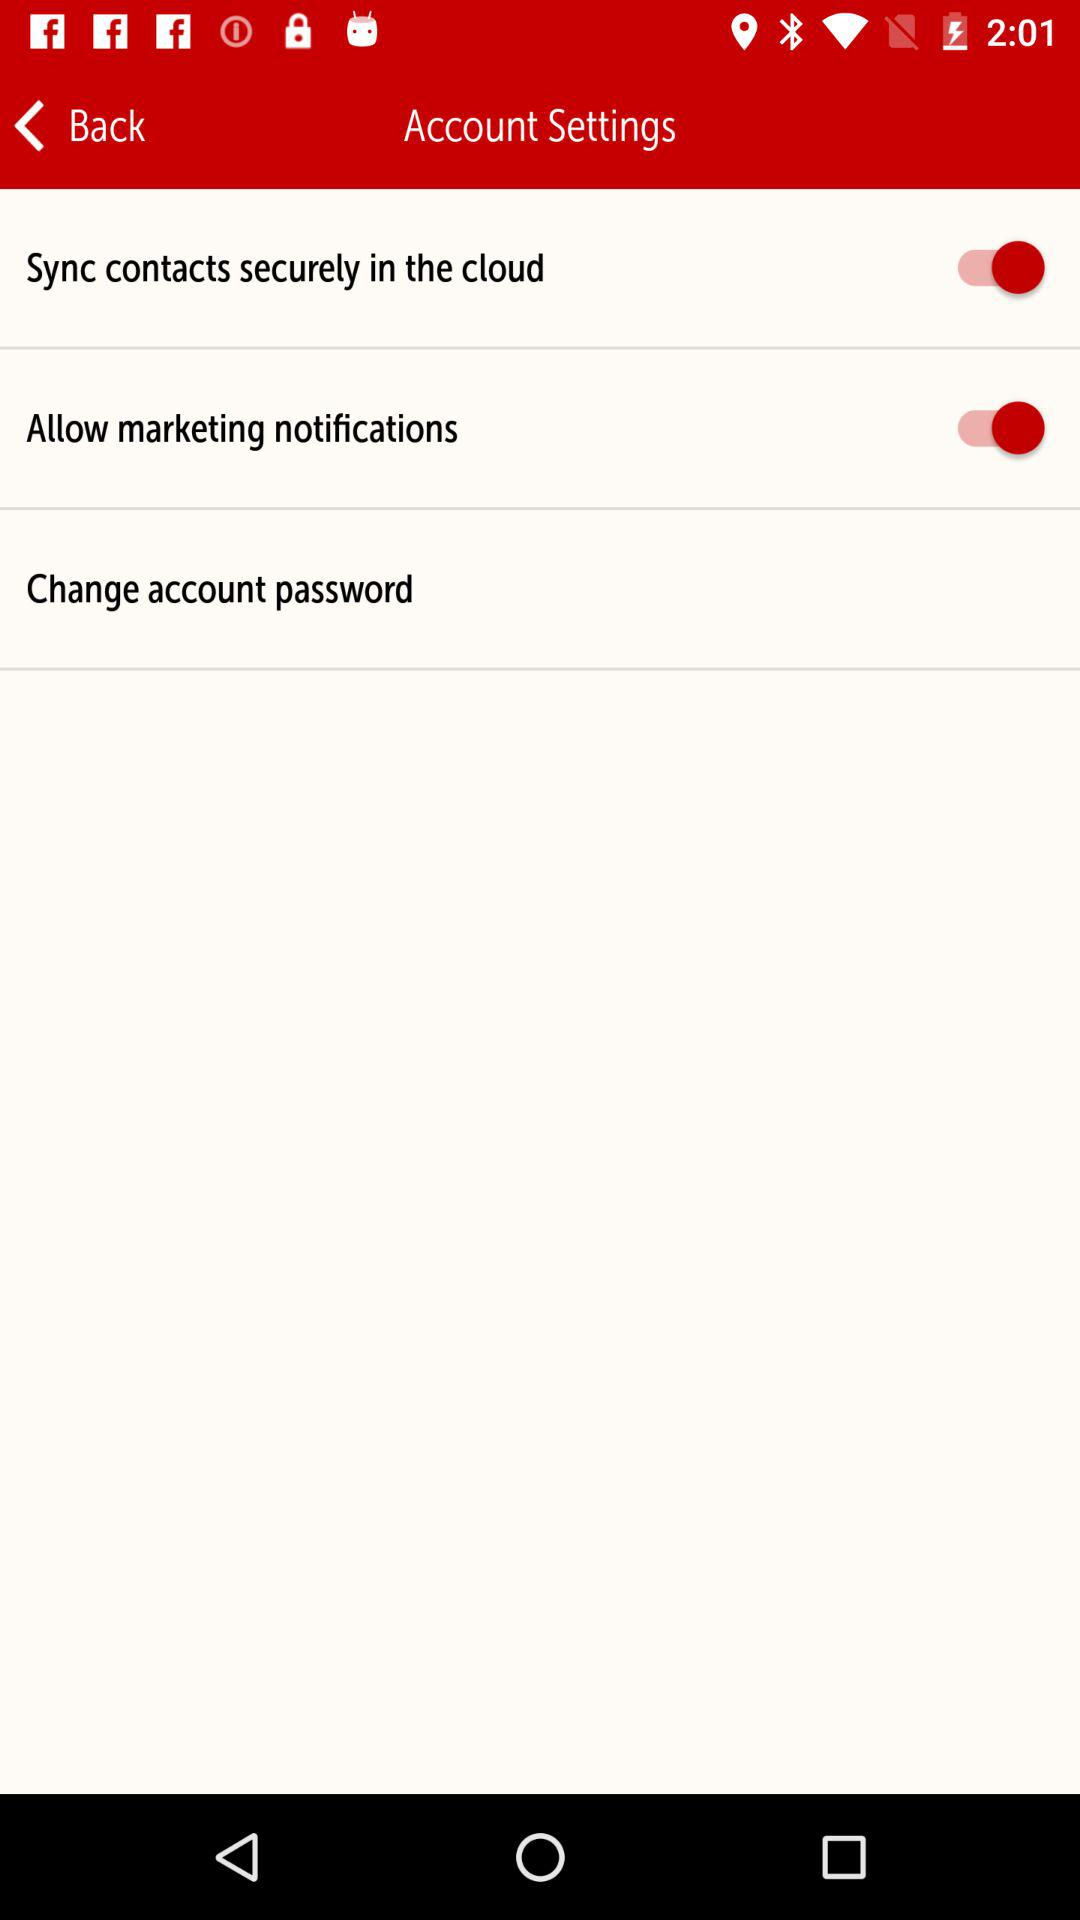What is the status of the "Sync contacts"? The status is "on". 